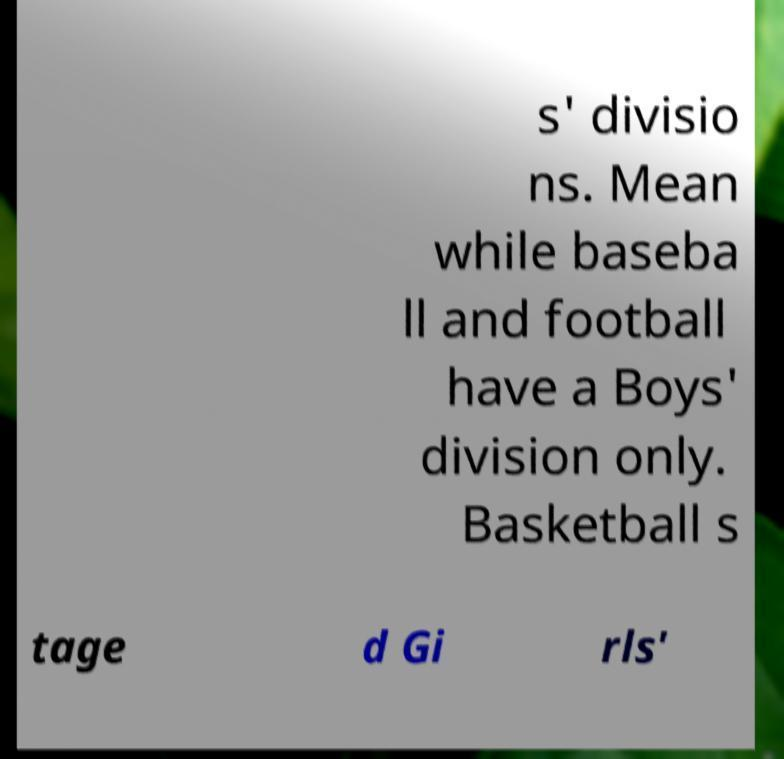For documentation purposes, I need the text within this image transcribed. Could you provide that? s' divisio ns. Mean while baseba ll and football have a Boys' division only. Basketball s tage d Gi rls' 